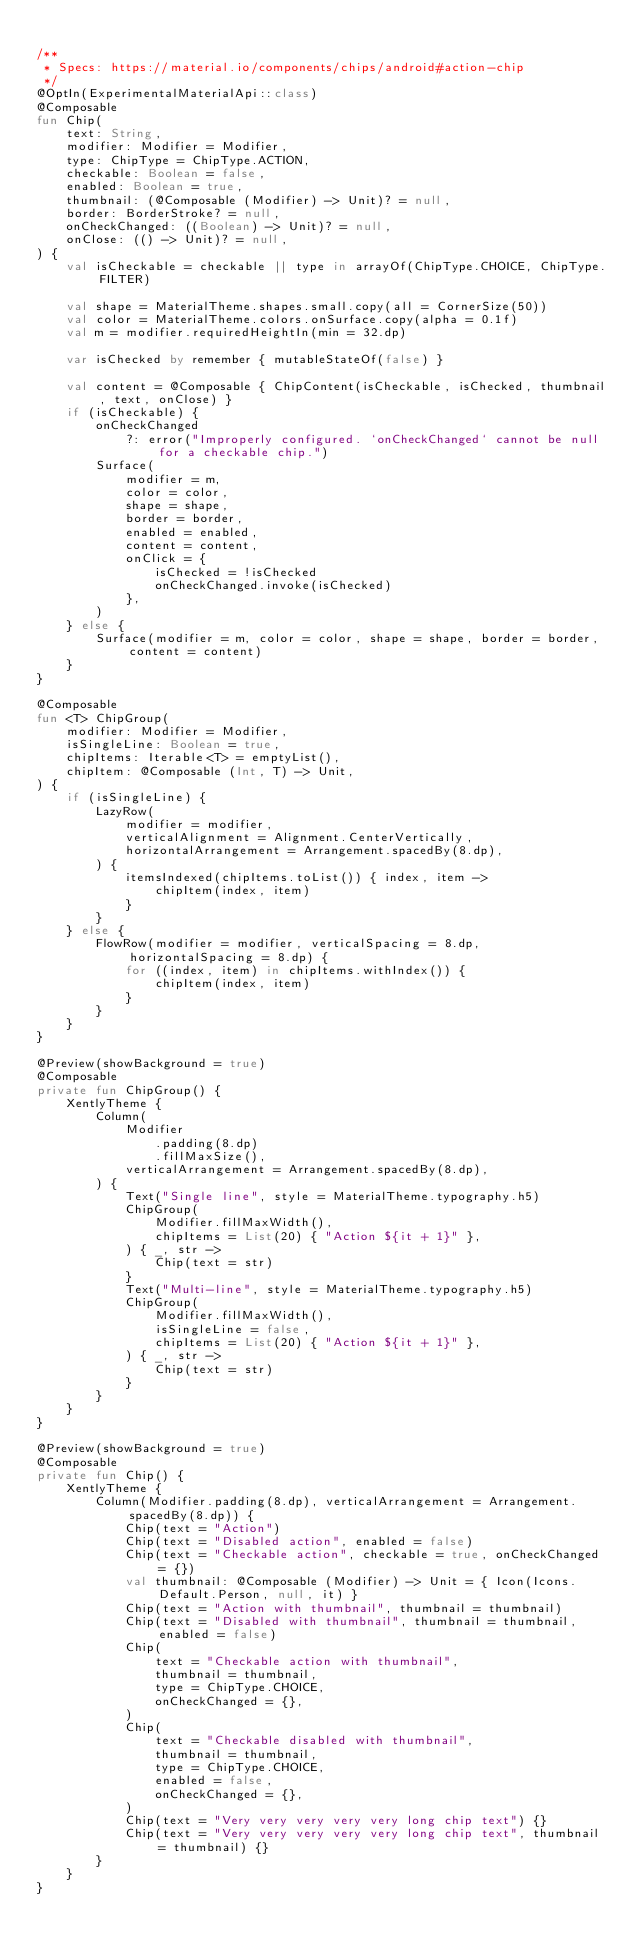Convert code to text. <code><loc_0><loc_0><loc_500><loc_500><_Kotlin_>
/**
 * Specs: https://material.io/components/chips/android#action-chip
 */
@OptIn(ExperimentalMaterialApi::class)
@Composable
fun Chip(
    text: String,
    modifier: Modifier = Modifier,
    type: ChipType = ChipType.ACTION,
    checkable: Boolean = false,
    enabled: Boolean = true,
    thumbnail: (@Composable (Modifier) -> Unit)? = null,
    border: BorderStroke? = null,
    onCheckChanged: ((Boolean) -> Unit)? = null,
    onClose: (() -> Unit)? = null,
) {
    val isCheckable = checkable || type in arrayOf(ChipType.CHOICE, ChipType.FILTER)

    val shape = MaterialTheme.shapes.small.copy(all = CornerSize(50))
    val color = MaterialTheme.colors.onSurface.copy(alpha = 0.1f)
    val m = modifier.requiredHeightIn(min = 32.dp)

    var isChecked by remember { mutableStateOf(false) }

    val content = @Composable { ChipContent(isCheckable, isChecked, thumbnail, text, onClose) }
    if (isCheckable) {
        onCheckChanged
            ?: error("Improperly configured. `onCheckChanged` cannot be null for a checkable chip.")
        Surface(
            modifier = m,
            color = color,
            shape = shape,
            border = border,
            enabled = enabled,
            content = content,
            onClick = {
                isChecked = !isChecked
                onCheckChanged.invoke(isChecked)
            },
        )
    } else {
        Surface(modifier = m, color = color, shape = shape, border = border, content = content)
    }
}

@Composable
fun <T> ChipGroup(
    modifier: Modifier = Modifier,
    isSingleLine: Boolean = true,
    chipItems: Iterable<T> = emptyList(),
    chipItem: @Composable (Int, T) -> Unit,
) {
    if (isSingleLine) {
        LazyRow(
            modifier = modifier,
            verticalAlignment = Alignment.CenterVertically,
            horizontalArrangement = Arrangement.spacedBy(8.dp),
        ) {
            itemsIndexed(chipItems.toList()) { index, item ->
                chipItem(index, item)
            }
        }
    } else {
        FlowRow(modifier = modifier, verticalSpacing = 8.dp, horizontalSpacing = 8.dp) {
            for ((index, item) in chipItems.withIndex()) {
                chipItem(index, item)
            }
        }
    }
}

@Preview(showBackground = true)
@Composable
private fun ChipGroup() {
    XentlyTheme {
        Column(
            Modifier
                .padding(8.dp)
                .fillMaxSize(),
            verticalArrangement = Arrangement.spacedBy(8.dp),
        ) {
            Text("Single line", style = MaterialTheme.typography.h5)
            ChipGroup(
                Modifier.fillMaxWidth(),
                chipItems = List(20) { "Action ${it + 1}" },
            ) { _, str ->
                Chip(text = str)
            }
            Text("Multi-line", style = MaterialTheme.typography.h5)
            ChipGroup(
                Modifier.fillMaxWidth(),
                isSingleLine = false,
                chipItems = List(20) { "Action ${it + 1}" },
            ) { _, str ->
                Chip(text = str)
            }
        }
    }
}

@Preview(showBackground = true)
@Composable
private fun Chip() {
    XentlyTheme {
        Column(Modifier.padding(8.dp), verticalArrangement = Arrangement.spacedBy(8.dp)) {
            Chip(text = "Action")
            Chip(text = "Disabled action", enabled = false)
            Chip(text = "Checkable action", checkable = true, onCheckChanged = {})
            val thumbnail: @Composable (Modifier) -> Unit = { Icon(Icons.Default.Person, null, it) }
            Chip(text = "Action with thumbnail", thumbnail = thumbnail)
            Chip(text = "Disabled with thumbnail", thumbnail = thumbnail, enabled = false)
            Chip(
                text = "Checkable action with thumbnail",
                thumbnail = thumbnail,
                type = ChipType.CHOICE,
                onCheckChanged = {},
            )
            Chip(
                text = "Checkable disabled with thumbnail",
                thumbnail = thumbnail,
                type = ChipType.CHOICE,
                enabled = false,
                onCheckChanged = {},
            )
            Chip(text = "Very very very very very long chip text") {}
            Chip(text = "Very very very very very long chip text", thumbnail = thumbnail) {}
        }
    }
}</code> 